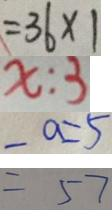<formula> <loc_0><loc_0><loc_500><loc_500>= 3 6 \times 1 
 x : 3 
 - a = 5 
 = 5 7</formula> 